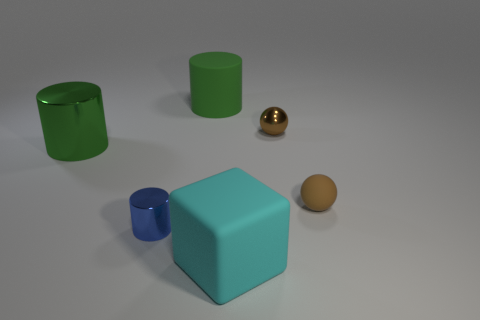Subtract all gray balls. How many green cylinders are left? 2 Add 2 small cylinders. How many objects exist? 8 Subtract all small blue metallic cylinders. How many cylinders are left? 2 Subtract all blue cylinders. How many cylinders are left? 2 Subtract all cubes. How many objects are left? 5 Subtract all red cylinders. Subtract all red spheres. How many cylinders are left? 3 Add 5 cylinders. How many cylinders exist? 8 Subtract 0 cyan cylinders. How many objects are left? 6 Subtract all tiny cyan metal spheres. Subtract all brown rubber things. How many objects are left? 5 Add 4 brown metallic spheres. How many brown metallic spheres are left? 5 